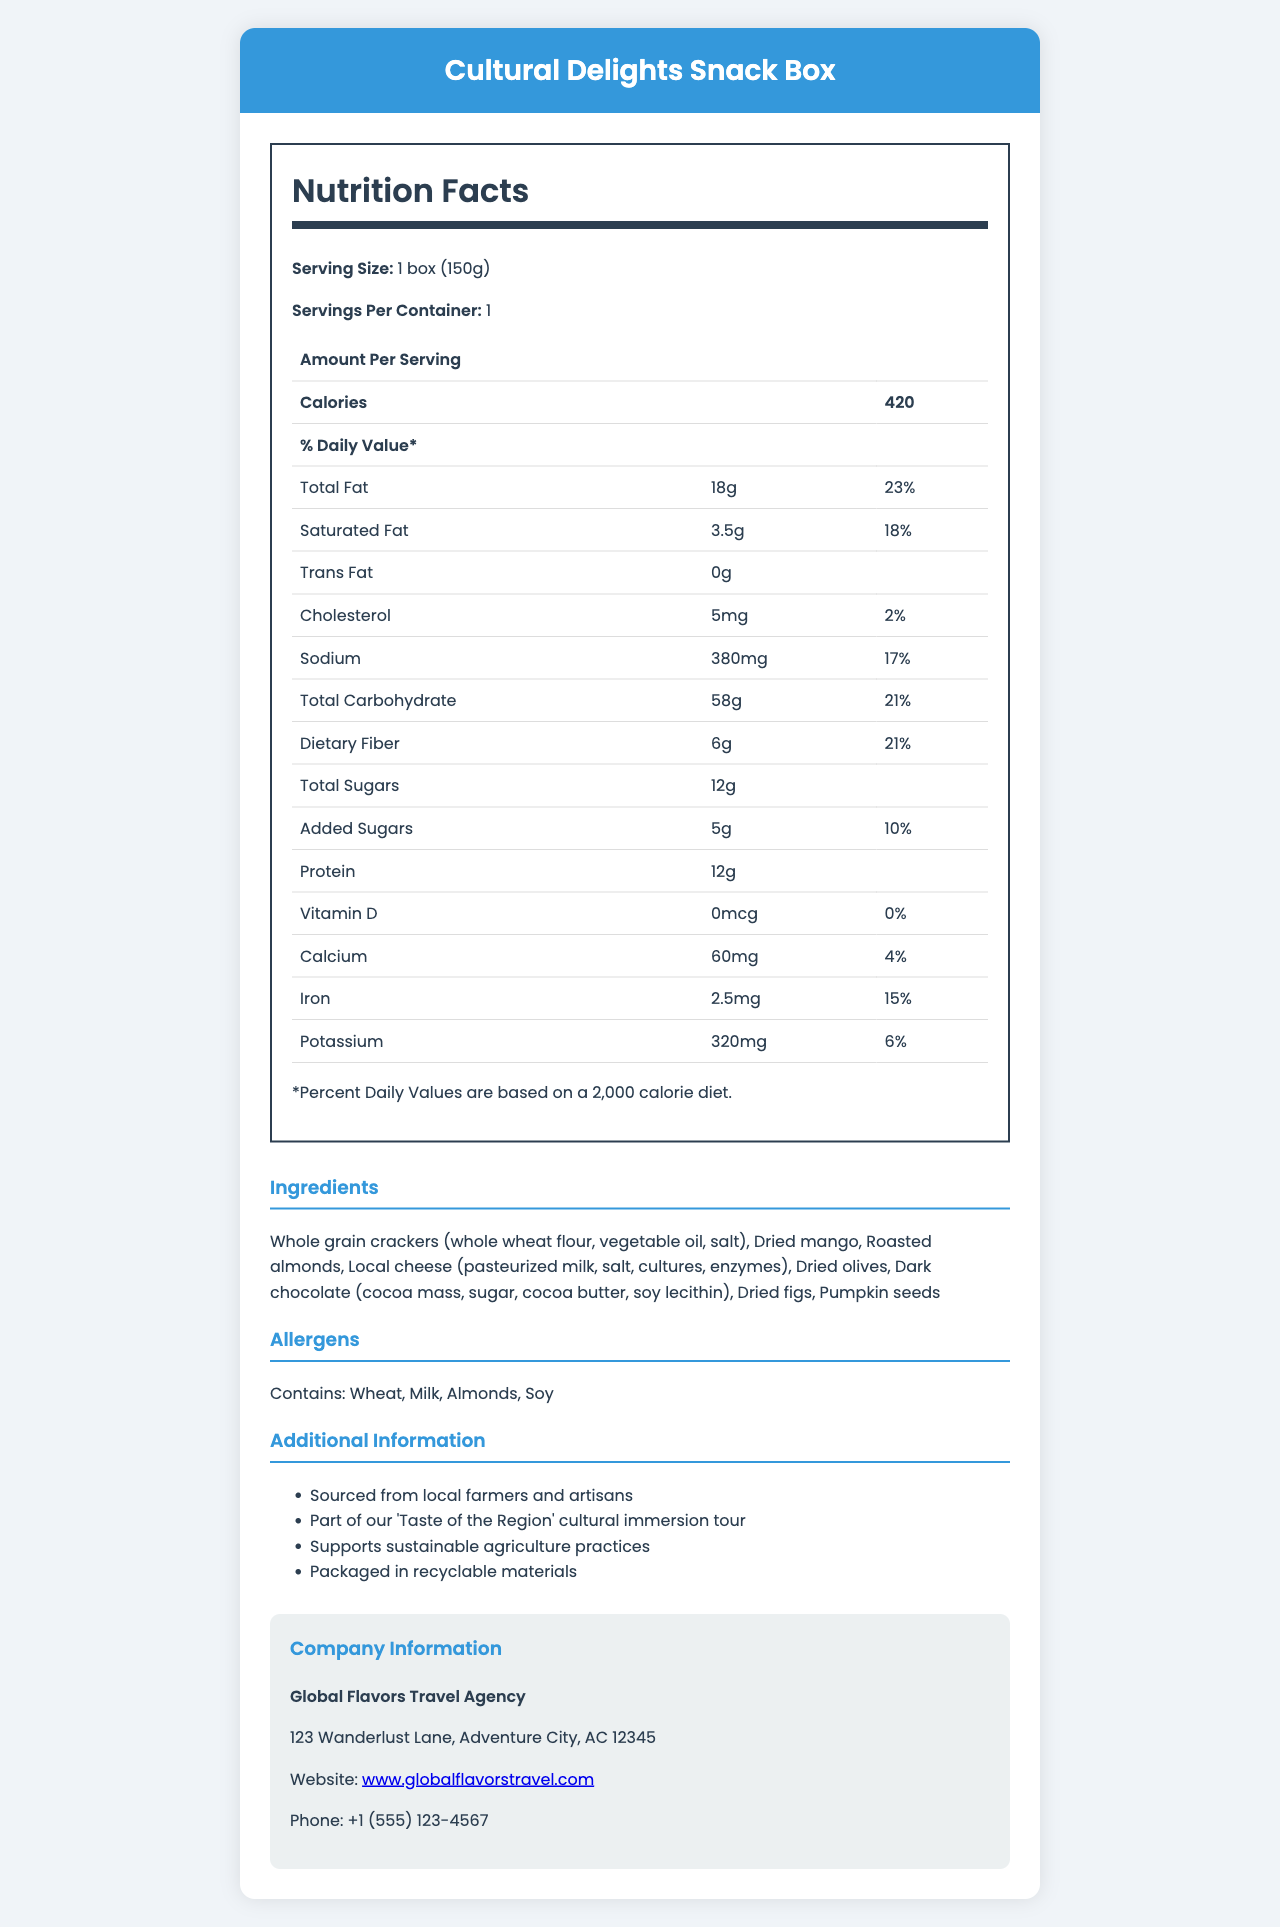what is the serving size of the Cultural Delights Snack Box? The serving size is clearly mentioned as "1 box (150g)" in the nutrition facts section.
Answer: 1 box (150g) how many calories are there per serving? The document lists the calories per serving as 420.
Answer: 420 what are the total grams of fat in one serving? According to the nutrition facts, the total fat per serving is 18g.
Answer: 18g what percentage of the daily value of cholesterol is in one serving? The document shows that the daily value percentage for cholesterol is 2%.
Answer: 2% how much fiber is in one serving? The dietary fiber content per serving is specified as 6g in the nutrition facts.
Answer: 6g which ingredient is not listed in the ingredients section? A. Roasted Almonds B. Dried Figs C. Honey D. Whole Grain Crackers Honey is not listed among the ingredients; all others (Roasted Almonds, Dried Figs, Whole Grain Crackers) are included.
Answer: C. Honey how much added sugar does the snack box contain? The amount of added sugars is specified as 5g.
Answer: 5g what is the total carbohydrate content per serving, and what percentage of the daily value does it represent? The document lists the total carbohydrate content as 58g, which represents 21% of the daily value.
Answer: 58g, 21% does the Cultural Delights Snack Box contain soy? The allergens section specifies that the snack box contains soy.
Answer: Yes describe the main idea of this document. The document is focused on listing all the nutrition facts, ingredients, allergens, and other relevant information about the Cultural Delights Snack Box, including company information for Global Flavors Travel Agency.
Answer: The document provides detailed nutrition facts, ingredients, allergens, and additional information about the Cultural Delights Snack Box, a product offered by Global Flavors Travel Agency that is part of a cultural immersion tour. Various health metrics and company contact information are listed to give a comprehensive overview of the snack box. what is the amount of protein in one serving? The amount of protein per serving is 12g.
Answer: 12g how many grams of saturated fat are in the snack box, and what percentage of the daily value does this constitute? The saturated fat content is 3.5g, which constitutes 18% of the daily value.
Answer: 3.5g, 18% which vitamin is not present in the snack box according to the nutrition label? A. Vitamin D B. Calcium C. Iron D. Potassium The label indicates that the snack box contains 0mcg of Vitamin D, which is 0% of the daily value.
Answer: A. Vitamin D how many servings are there per container? The document specifies that there is 1 serving per container.
Answer: 1 what sustainable practice does the Cultural Delights Snack Box support? The additional information section mentions that the snack box supports sustainable agriculture practices.
Answer: Sustainable agriculture practices where is the Global Flavors Travel Agency located? The company information section provides the address.
Answer: 123 Wanderlust Lane, Adventure City, AC 12345 what types of dried fruits are included in the snack box? The ingredients section lists dried mango, dried olives, and dried figs as the dried fruits included in the snack box.
Answer: Dried mango, Dried olives, Dried figs what percentage of the daily value of potassium is provided per serving? The nutrition facts list the potassium daily value percentage as 6%.
Answer: 6% who is the manufacturer of the Cultural Delights Snack Box? The document does not provide detailed information about the manufacturer; it only mentions that the product is offered by Global Flavors Travel Agency.
Answer: Cannot be determined is there information provided about recyclable packaging? The additional information section clearly states that the snack box is packaged in recyclable materials.
Answer: Yes 